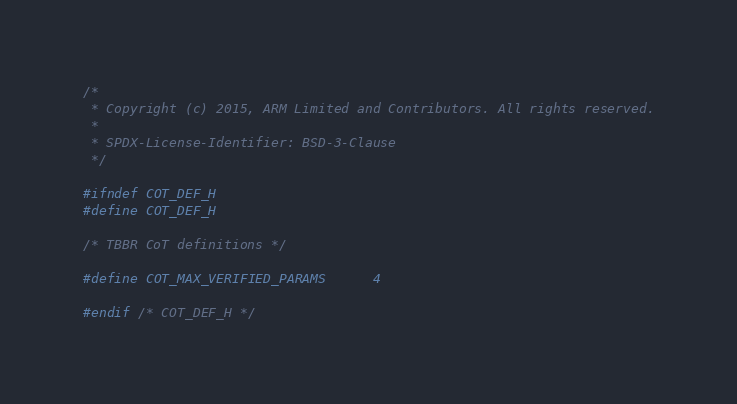<code> <loc_0><loc_0><loc_500><loc_500><_C_>/*
 * Copyright (c) 2015, ARM Limited and Contributors. All rights reserved.
 *
 * SPDX-License-Identifier: BSD-3-Clause
 */

#ifndef COT_DEF_H
#define COT_DEF_H

/* TBBR CoT definitions */

#define COT_MAX_VERIFIED_PARAMS		4

#endif /* COT_DEF_H */
</code> 